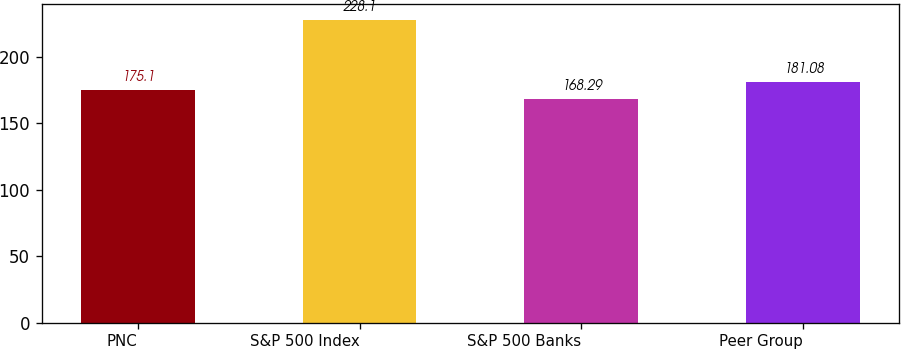<chart> <loc_0><loc_0><loc_500><loc_500><bar_chart><fcel>PNC<fcel>S&P 500 Index<fcel>S&P 500 Banks<fcel>Peer Group<nl><fcel>175.1<fcel>228.1<fcel>168.29<fcel>181.08<nl></chart> 